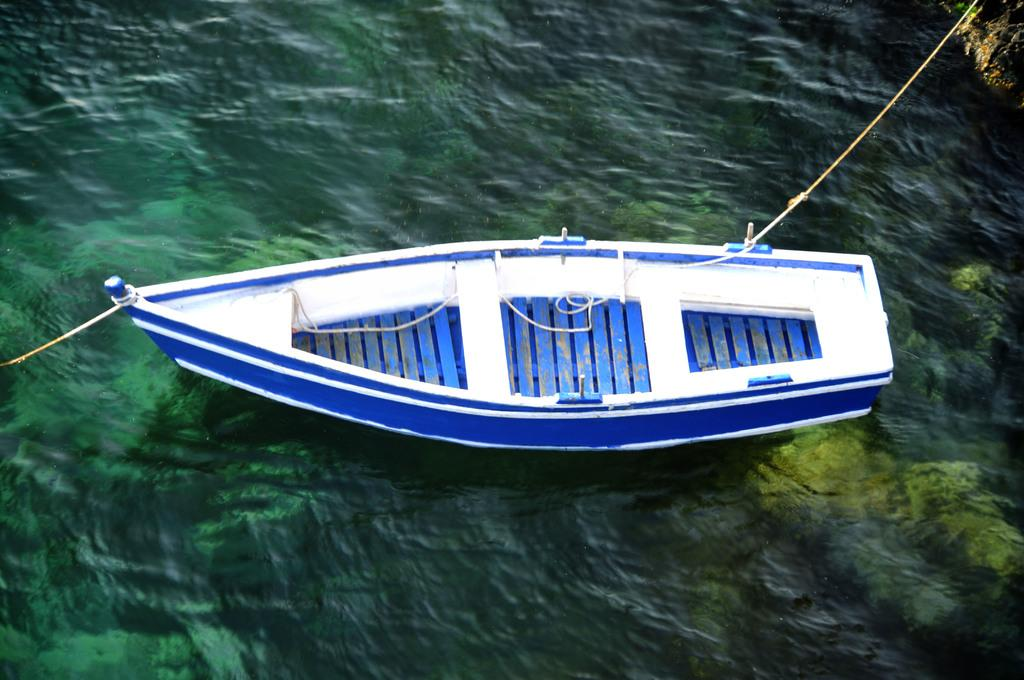What is the main subject of the picture? The main subject of the picture is a boat. What is the boat doing in the picture? The boat is sailing on the water. What colors can be seen on the boat? The boat is in blue and white color. Can you see the face of the person driving the boat in the image? There is no person driving the boat visible in the image. What type of table is present on the boat in the image? There is no table present on the boat in the image. 